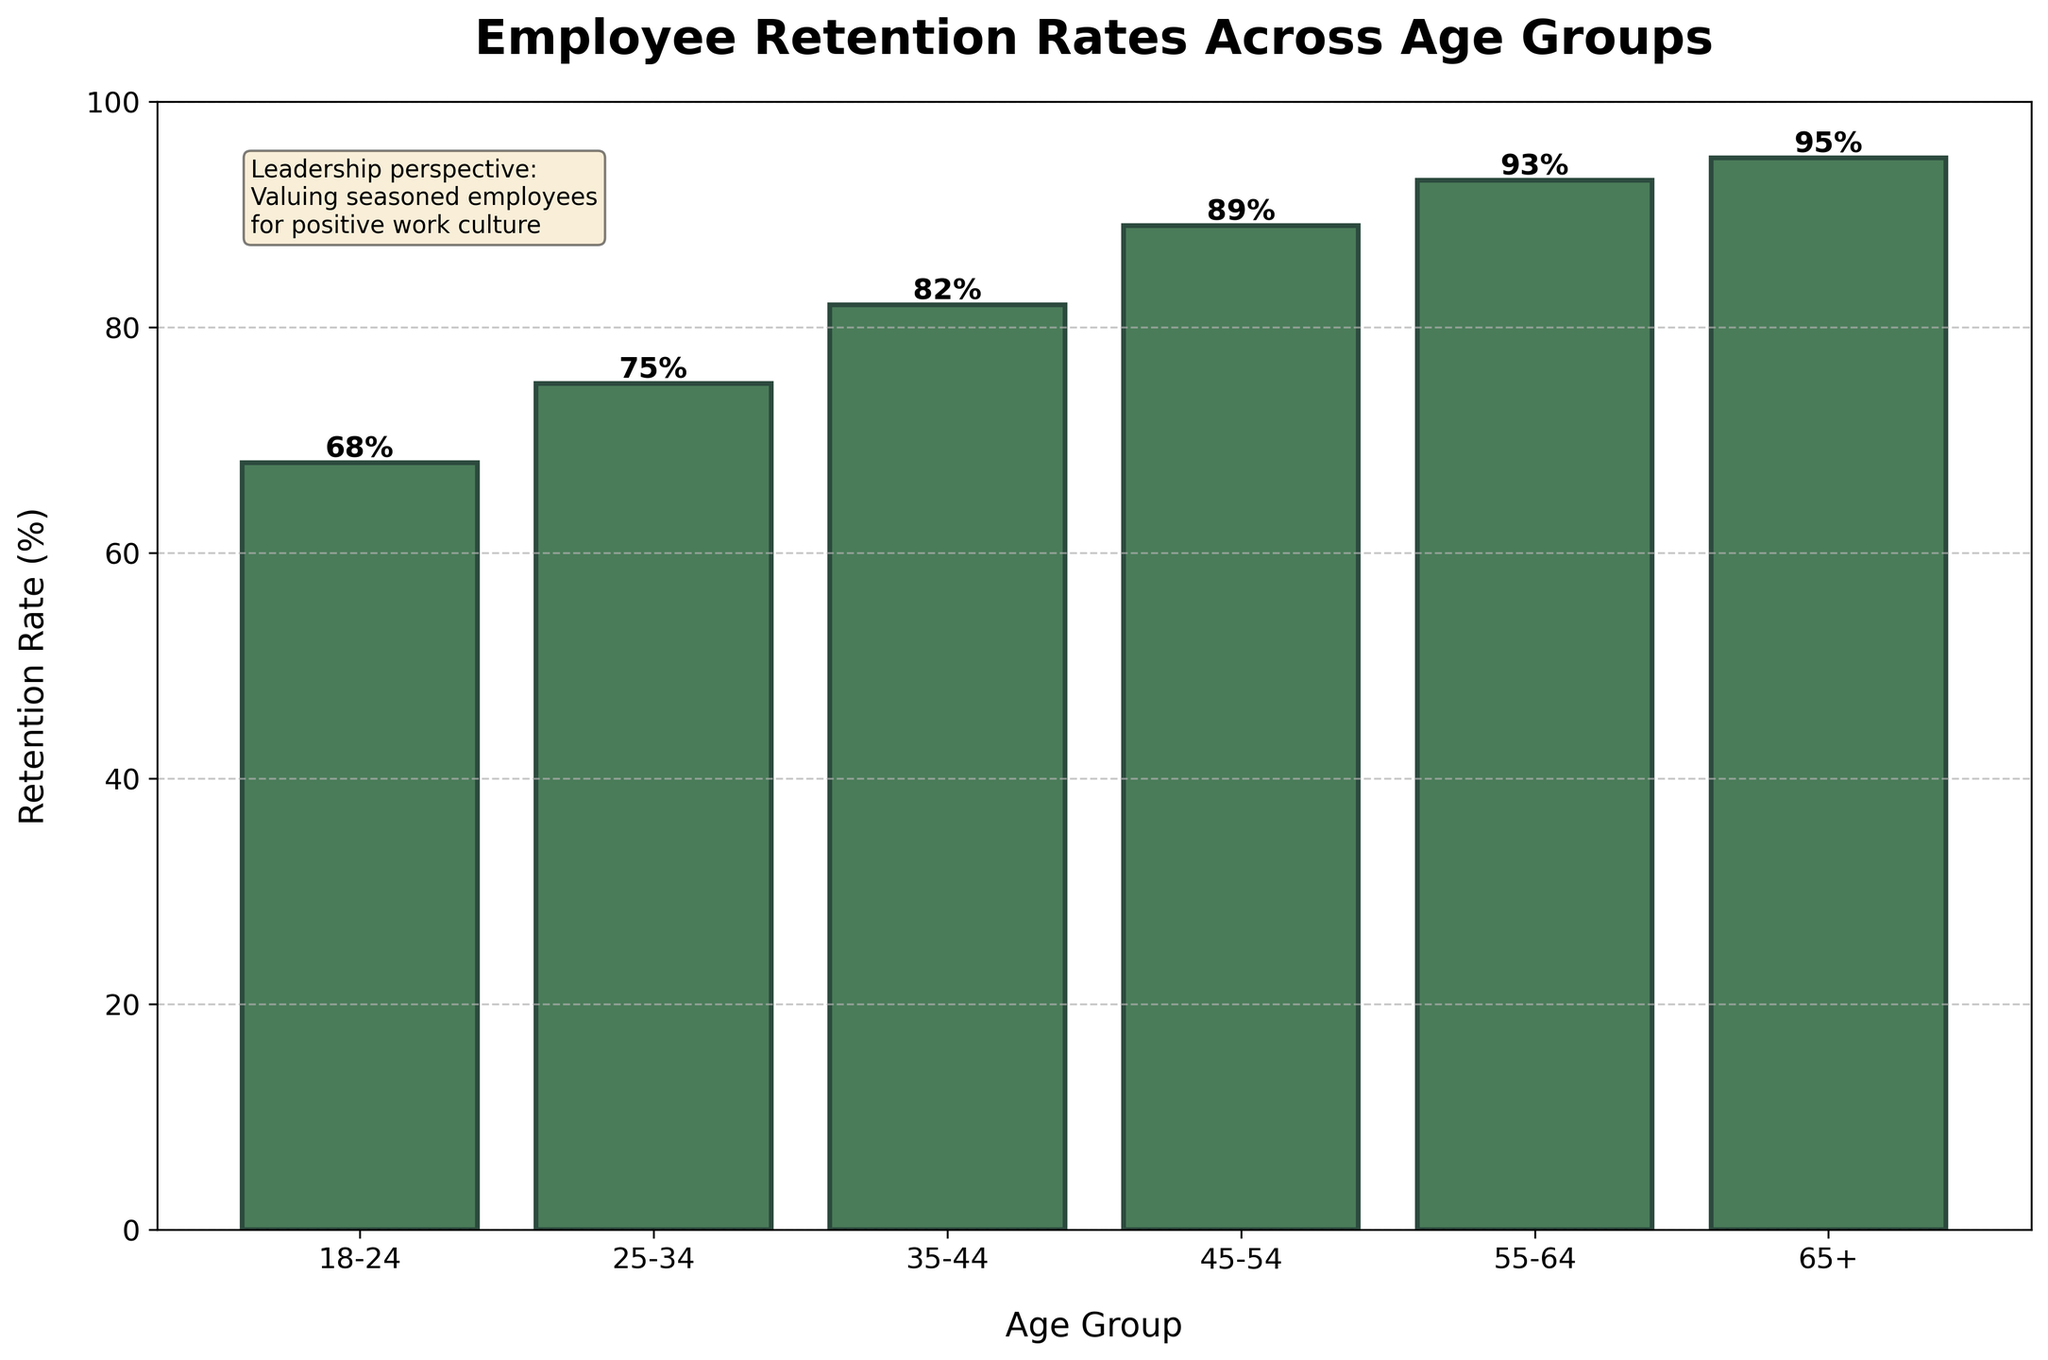Which age group has the highest retention rate? By observing the height of the bars in the bar chart, the 65+ age group has the tallest bar, indicating the highest retention rate.
Answer: 65+ What is the difference in retention rates between the 18-24 and 55-64 age groups? The retention rate for the 18-24 age group is 68%, and for the 55-64 age group, it is 93%. The difference is calculated by subtracting 68 from 93.
Answer: 25% Which age groups have retention rates above 80%? The bars representing the age groups 35-44, 45-54, 55-64, and 65+ all exceed the 80% mark on the y-axis.
Answer: 35-44, 45-54, 55-64, 65+ How does the retention rate change from the 35-44 age group to the 45-54 age group? The retention rate increases from 82% for the 35-44 age group to 89% for the 45-54 age group. This shows a growth in retention by examining the difference between these two numbers.
Answer: Increases by 7% Comparing the retention rates of the 25-34 and 35-44 age groups, which is higher and by how much? The retention rate for the 25-34 age group is 75%, while it is 82% for the 35-44 age group. By subtracting 75 from 82, we find that the 35-44 age group has a higher retention rate by 7%.
Answer: 35-44 by 7% What is the average retention rate for employees aged 35-44 and older? The retention rates for the age groups 35-44, 45-54, 55-64, and 65+ are 82%, 89%, 93%, and 95%, respectively. The average is calculated by summing these rates and dividing by the number of age groups: (82 + 89 + 93 + 95) / 4 = 89.75%.
Answer: 89.75% What visual features of the chart emphasize the retention rate for the 65+ age group? The bar for the 65+ age group is the tallest, reaching the highest point on the y-axis close to 100%, and it has a value label on top displaying 95%, making it visually prominent.
Answer: Tallest bar, close to 100%, value label 95% Do older age groups tend to have higher retention rates compared to younger age groups? By examining the progression of the bar heights from younger to older age groups, it is evident that retention rates increase, with each subsequent age group generally showing higher values.
Answer: Yes What is the combined retention rate of the youngest and oldest age groups? The retention rates for the 18-24 and 65+ age groups are 68% and 95%, respectively. Summing these rates gives 68 + 95 = 163%.
Answer: 163% Based on the chart, how does the addition of a box with the persona contribute to the understanding of the data? The text box highlights the company's recognition of seasoned employees' contributions to a positive work culture, which aligns with the higher retention rates observed for older age groups, reinforcing the connection between retention and workplace culture.
Answer: Reinforces connection between retention and workplace culture 